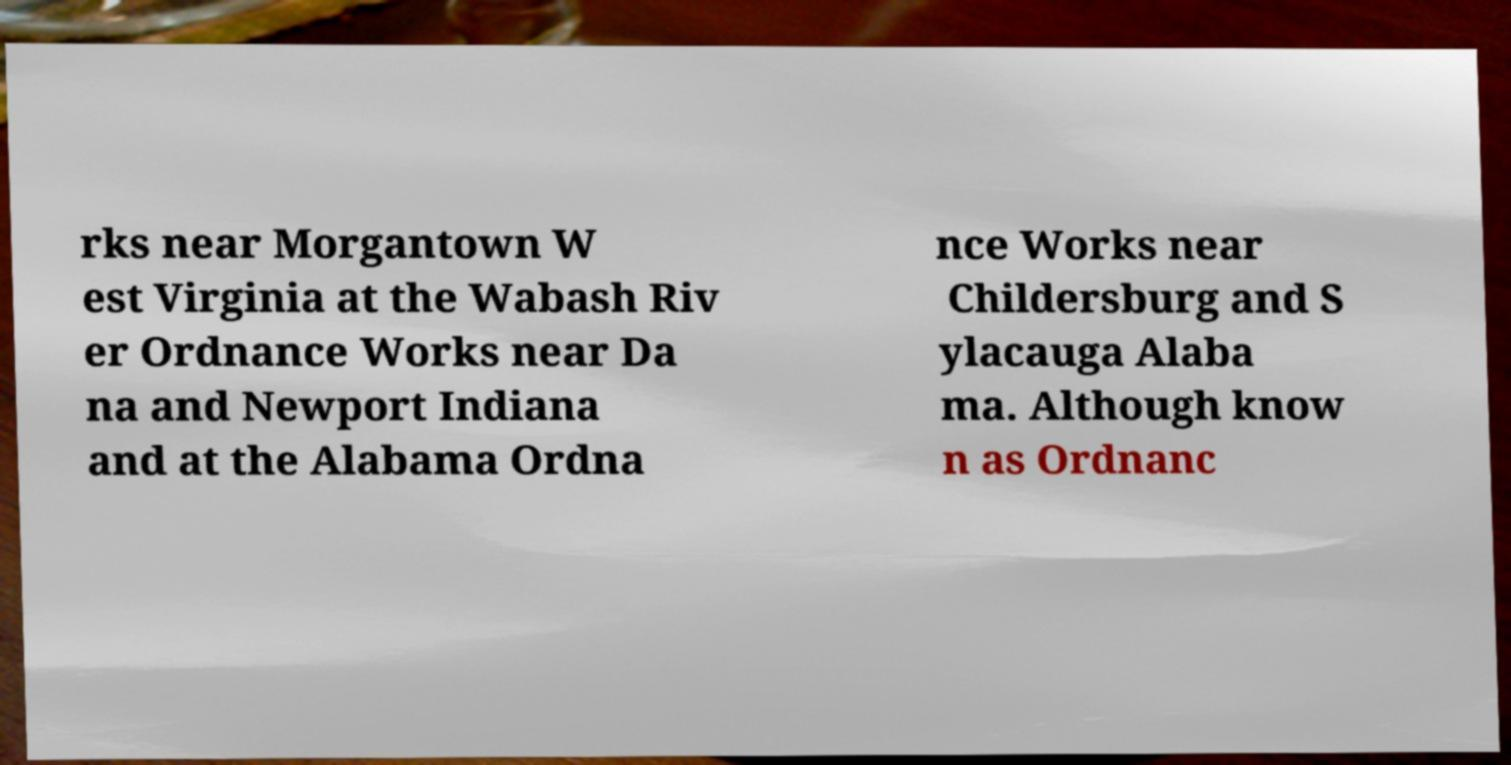Could you assist in decoding the text presented in this image and type it out clearly? rks near Morgantown W est Virginia at the Wabash Riv er Ordnance Works near Da na and Newport Indiana and at the Alabama Ordna nce Works near Childersburg and S ylacauga Alaba ma. Although know n as Ordnanc 